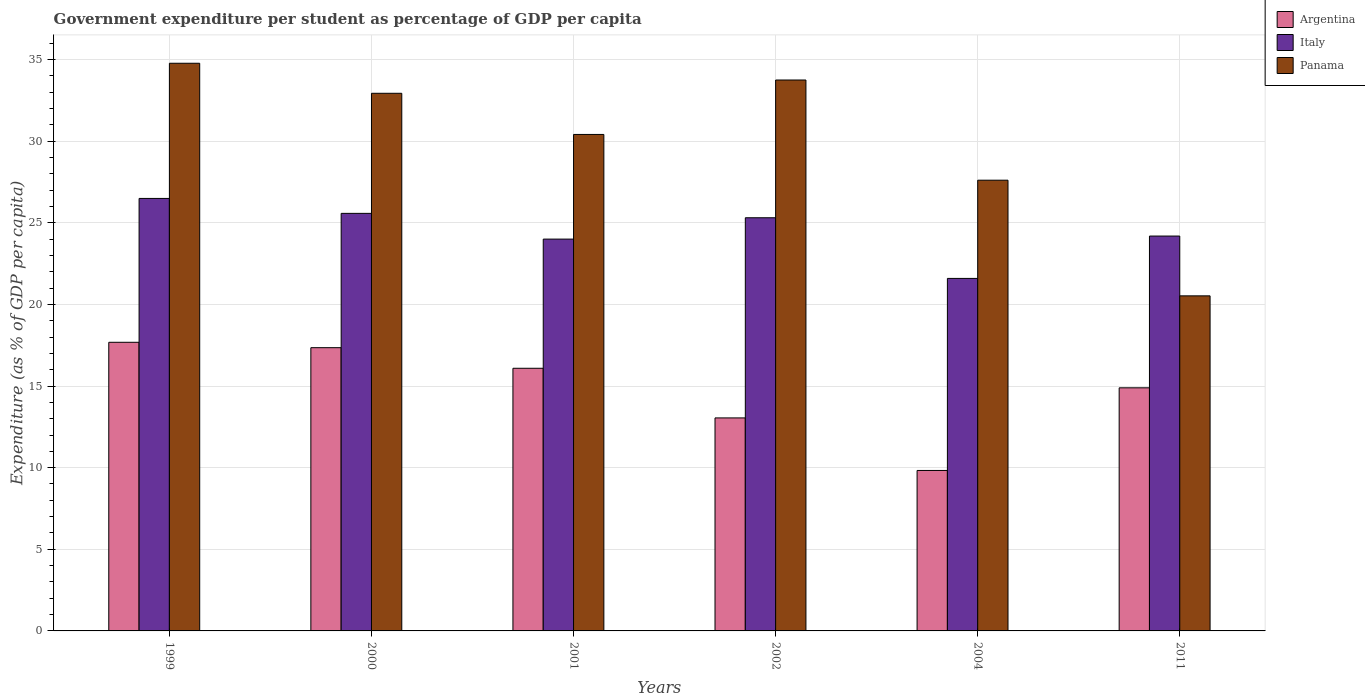How many groups of bars are there?
Offer a terse response. 6. Are the number of bars per tick equal to the number of legend labels?
Provide a short and direct response. Yes. Are the number of bars on each tick of the X-axis equal?
Offer a very short reply. Yes. How many bars are there on the 4th tick from the left?
Your answer should be very brief. 3. What is the percentage of expenditure per student in Panama in 1999?
Your answer should be compact. 34.77. Across all years, what is the maximum percentage of expenditure per student in Argentina?
Offer a terse response. 17.68. Across all years, what is the minimum percentage of expenditure per student in Argentina?
Provide a succinct answer. 9.83. In which year was the percentage of expenditure per student in Argentina maximum?
Provide a succinct answer. 1999. What is the total percentage of expenditure per student in Italy in the graph?
Ensure brevity in your answer.  147.15. What is the difference between the percentage of expenditure per student in Argentina in 2001 and that in 2002?
Provide a succinct answer. 3.04. What is the difference between the percentage of expenditure per student in Argentina in 2000 and the percentage of expenditure per student in Italy in 2004?
Provide a succinct answer. -4.24. What is the average percentage of expenditure per student in Argentina per year?
Ensure brevity in your answer.  14.81. In the year 1999, what is the difference between the percentage of expenditure per student in Argentina and percentage of expenditure per student in Panama?
Offer a terse response. -17.09. In how many years, is the percentage of expenditure per student in Argentina greater than 14 %?
Your response must be concise. 4. What is the ratio of the percentage of expenditure per student in Argentina in 2000 to that in 2002?
Your answer should be very brief. 1.33. Is the percentage of expenditure per student in Argentina in 2000 less than that in 2002?
Make the answer very short. No. Is the difference between the percentage of expenditure per student in Argentina in 2002 and 2011 greater than the difference between the percentage of expenditure per student in Panama in 2002 and 2011?
Your answer should be compact. No. What is the difference between the highest and the second highest percentage of expenditure per student in Italy?
Offer a very short reply. 0.92. What is the difference between the highest and the lowest percentage of expenditure per student in Panama?
Your answer should be very brief. 14.25. In how many years, is the percentage of expenditure per student in Argentina greater than the average percentage of expenditure per student in Argentina taken over all years?
Ensure brevity in your answer.  4. What does the 3rd bar from the left in 2000 represents?
Your response must be concise. Panama. What does the 1st bar from the right in 2011 represents?
Provide a short and direct response. Panama. How many bars are there?
Make the answer very short. 18. What is the difference between two consecutive major ticks on the Y-axis?
Offer a terse response. 5. Where does the legend appear in the graph?
Provide a short and direct response. Top right. How many legend labels are there?
Give a very brief answer. 3. What is the title of the graph?
Your response must be concise. Government expenditure per student as percentage of GDP per capita. What is the label or title of the Y-axis?
Provide a short and direct response. Expenditure (as % of GDP per capita). What is the Expenditure (as % of GDP per capita) of Argentina in 1999?
Offer a very short reply. 17.68. What is the Expenditure (as % of GDP per capita) of Italy in 1999?
Give a very brief answer. 26.49. What is the Expenditure (as % of GDP per capita) in Panama in 1999?
Offer a terse response. 34.77. What is the Expenditure (as % of GDP per capita) in Argentina in 2000?
Make the answer very short. 17.35. What is the Expenditure (as % of GDP per capita) in Italy in 2000?
Give a very brief answer. 25.57. What is the Expenditure (as % of GDP per capita) of Panama in 2000?
Offer a terse response. 32.93. What is the Expenditure (as % of GDP per capita) in Argentina in 2001?
Give a very brief answer. 16.09. What is the Expenditure (as % of GDP per capita) in Italy in 2001?
Keep it short and to the point. 24. What is the Expenditure (as % of GDP per capita) in Panama in 2001?
Keep it short and to the point. 30.41. What is the Expenditure (as % of GDP per capita) of Argentina in 2002?
Your response must be concise. 13.05. What is the Expenditure (as % of GDP per capita) of Italy in 2002?
Your answer should be very brief. 25.31. What is the Expenditure (as % of GDP per capita) in Panama in 2002?
Keep it short and to the point. 33.74. What is the Expenditure (as % of GDP per capita) in Argentina in 2004?
Give a very brief answer. 9.83. What is the Expenditure (as % of GDP per capita) of Italy in 2004?
Your answer should be compact. 21.59. What is the Expenditure (as % of GDP per capita) in Panama in 2004?
Keep it short and to the point. 27.61. What is the Expenditure (as % of GDP per capita) of Argentina in 2011?
Offer a terse response. 14.89. What is the Expenditure (as % of GDP per capita) in Italy in 2011?
Your answer should be compact. 24.19. What is the Expenditure (as % of GDP per capita) in Panama in 2011?
Provide a succinct answer. 20.52. Across all years, what is the maximum Expenditure (as % of GDP per capita) in Argentina?
Ensure brevity in your answer.  17.68. Across all years, what is the maximum Expenditure (as % of GDP per capita) in Italy?
Offer a very short reply. 26.49. Across all years, what is the maximum Expenditure (as % of GDP per capita) of Panama?
Your answer should be very brief. 34.77. Across all years, what is the minimum Expenditure (as % of GDP per capita) in Argentina?
Offer a very short reply. 9.83. Across all years, what is the minimum Expenditure (as % of GDP per capita) in Italy?
Offer a very short reply. 21.59. Across all years, what is the minimum Expenditure (as % of GDP per capita) of Panama?
Your response must be concise. 20.52. What is the total Expenditure (as % of GDP per capita) of Argentina in the graph?
Give a very brief answer. 88.88. What is the total Expenditure (as % of GDP per capita) in Italy in the graph?
Make the answer very short. 147.15. What is the total Expenditure (as % of GDP per capita) in Panama in the graph?
Offer a very short reply. 179.98. What is the difference between the Expenditure (as % of GDP per capita) of Argentina in 1999 and that in 2000?
Keep it short and to the point. 0.33. What is the difference between the Expenditure (as % of GDP per capita) of Italy in 1999 and that in 2000?
Provide a succinct answer. 0.92. What is the difference between the Expenditure (as % of GDP per capita) in Panama in 1999 and that in 2000?
Give a very brief answer. 1.84. What is the difference between the Expenditure (as % of GDP per capita) of Argentina in 1999 and that in 2001?
Make the answer very short. 1.59. What is the difference between the Expenditure (as % of GDP per capita) in Italy in 1999 and that in 2001?
Ensure brevity in your answer.  2.49. What is the difference between the Expenditure (as % of GDP per capita) of Panama in 1999 and that in 2001?
Offer a terse response. 4.36. What is the difference between the Expenditure (as % of GDP per capita) of Argentina in 1999 and that in 2002?
Offer a very short reply. 4.63. What is the difference between the Expenditure (as % of GDP per capita) of Italy in 1999 and that in 2002?
Offer a terse response. 1.18. What is the difference between the Expenditure (as % of GDP per capita) in Panama in 1999 and that in 2002?
Your response must be concise. 1.03. What is the difference between the Expenditure (as % of GDP per capita) in Argentina in 1999 and that in 2004?
Provide a short and direct response. 7.85. What is the difference between the Expenditure (as % of GDP per capita) of Italy in 1999 and that in 2004?
Offer a very short reply. 4.9. What is the difference between the Expenditure (as % of GDP per capita) in Panama in 1999 and that in 2004?
Offer a terse response. 7.16. What is the difference between the Expenditure (as % of GDP per capita) in Argentina in 1999 and that in 2011?
Offer a very short reply. 2.79. What is the difference between the Expenditure (as % of GDP per capita) in Italy in 1999 and that in 2011?
Provide a short and direct response. 2.3. What is the difference between the Expenditure (as % of GDP per capita) of Panama in 1999 and that in 2011?
Offer a terse response. 14.25. What is the difference between the Expenditure (as % of GDP per capita) in Argentina in 2000 and that in 2001?
Your response must be concise. 1.26. What is the difference between the Expenditure (as % of GDP per capita) in Italy in 2000 and that in 2001?
Provide a succinct answer. 1.58. What is the difference between the Expenditure (as % of GDP per capita) in Panama in 2000 and that in 2001?
Keep it short and to the point. 2.52. What is the difference between the Expenditure (as % of GDP per capita) in Argentina in 2000 and that in 2002?
Offer a very short reply. 4.3. What is the difference between the Expenditure (as % of GDP per capita) of Italy in 2000 and that in 2002?
Make the answer very short. 0.27. What is the difference between the Expenditure (as % of GDP per capita) in Panama in 2000 and that in 2002?
Your answer should be compact. -0.81. What is the difference between the Expenditure (as % of GDP per capita) in Argentina in 2000 and that in 2004?
Offer a very short reply. 7.52. What is the difference between the Expenditure (as % of GDP per capita) of Italy in 2000 and that in 2004?
Give a very brief answer. 3.98. What is the difference between the Expenditure (as % of GDP per capita) in Panama in 2000 and that in 2004?
Ensure brevity in your answer.  5.32. What is the difference between the Expenditure (as % of GDP per capita) in Argentina in 2000 and that in 2011?
Keep it short and to the point. 2.46. What is the difference between the Expenditure (as % of GDP per capita) of Italy in 2000 and that in 2011?
Keep it short and to the point. 1.39. What is the difference between the Expenditure (as % of GDP per capita) of Panama in 2000 and that in 2011?
Offer a terse response. 12.41. What is the difference between the Expenditure (as % of GDP per capita) in Argentina in 2001 and that in 2002?
Provide a succinct answer. 3.04. What is the difference between the Expenditure (as % of GDP per capita) of Italy in 2001 and that in 2002?
Ensure brevity in your answer.  -1.31. What is the difference between the Expenditure (as % of GDP per capita) in Panama in 2001 and that in 2002?
Provide a short and direct response. -3.33. What is the difference between the Expenditure (as % of GDP per capita) of Argentina in 2001 and that in 2004?
Provide a succinct answer. 6.26. What is the difference between the Expenditure (as % of GDP per capita) of Italy in 2001 and that in 2004?
Ensure brevity in your answer.  2.41. What is the difference between the Expenditure (as % of GDP per capita) in Panama in 2001 and that in 2004?
Give a very brief answer. 2.8. What is the difference between the Expenditure (as % of GDP per capita) of Argentina in 2001 and that in 2011?
Give a very brief answer. 1.2. What is the difference between the Expenditure (as % of GDP per capita) in Italy in 2001 and that in 2011?
Provide a succinct answer. -0.19. What is the difference between the Expenditure (as % of GDP per capita) of Panama in 2001 and that in 2011?
Keep it short and to the point. 9.89. What is the difference between the Expenditure (as % of GDP per capita) of Argentina in 2002 and that in 2004?
Your response must be concise. 3.22. What is the difference between the Expenditure (as % of GDP per capita) in Italy in 2002 and that in 2004?
Offer a very short reply. 3.72. What is the difference between the Expenditure (as % of GDP per capita) in Panama in 2002 and that in 2004?
Give a very brief answer. 6.14. What is the difference between the Expenditure (as % of GDP per capita) of Argentina in 2002 and that in 2011?
Offer a terse response. -1.84. What is the difference between the Expenditure (as % of GDP per capita) in Italy in 2002 and that in 2011?
Your answer should be compact. 1.12. What is the difference between the Expenditure (as % of GDP per capita) in Panama in 2002 and that in 2011?
Your response must be concise. 13.22. What is the difference between the Expenditure (as % of GDP per capita) in Argentina in 2004 and that in 2011?
Ensure brevity in your answer.  -5.06. What is the difference between the Expenditure (as % of GDP per capita) of Italy in 2004 and that in 2011?
Provide a succinct answer. -2.59. What is the difference between the Expenditure (as % of GDP per capita) in Panama in 2004 and that in 2011?
Keep it short and to the point. 7.08. What is the difference between the Expenditure (as % of GDP per capita) in Argentina in 1999 and the Expenditure (as % of GDP per capita) in Italy in 2000?
Your answer should be compact. -7.9. What is the difference between the Expenditure (as % of GDP per capita) of Argentina in 1999 and the Expenditure (as % of GDP per capita) of Panama in 2000?
Your answer should be very brief. -15.25. What is the difference between the Expenditure (as % of GDP per capita) in Italy in 1999 and the Expenditure (as % of GDP per capita) in Panama in 2000?
Your answer should be very brief. -6.44. What is the difference between the Expenditure (as % of GDP per capita) of Argentina in 1999 and the Expenditure (as % of GDP per capita) of Italy in 2001?
Your answer should be compact. -6.32. What is the difference between the Expenditure (as % of GDP per capita) of Argentina in 1999 and the Expenditure (as % of GDP per capita) of Panama in 2001?
Keep it short and to the point. -12.73. What is the difference between the Expenditure (as % of GDP per capita) in Italy in 1999 and the Expenditure (as % of GDP per capita) in Panama in 2001?
Offer a terse response. -3.92. What is the difference between the Expenditure (as % of GDP per capita) in Argentina in 1999 and the Expenditure (as % of GDP per capita) in Italy in 2002?
Provide a short and direct response. -7.63. What is the difference between the Expenditure (as % of GDP per capita) in Argentina in 1999 and the Expenditure (as % of GDP per capita) in Panama in 2002?
Make the answer very short. -16.06. What is the difference between the Expenditure (as % of GDP per capita) of Italy in 1999 and the Expenditure (as % of GDP per capita) of Panama in 2002?
Keep it short and to the point. -7.25. What is the difference between the Expenditure (as % of GDP per capita) in Argentina in 1999 and the Expenditure (as % of GDP per capita) in Italy in 2004?
Provide a short and direct response. -3.91. What is the difference between the Expenditure (as % of GDP per capita) in Argentina in 1999 and the Expenditure (as % of GDP per capita) in Panama in 2004?
Make the answer very short. -9.93. What is the difference between the Expenditure (as % of GDP per capita) of Italy in 1999 and the Expenditure (as % of GDP per capita) of Panama in 2004?
Keep it short and to the point. -1.12. What is the difference between the Expenditure (as % of GDP per capita) in Argentina in 1999 and the Expenditure (as % of GDP per capita) in Italy in 2011?
Provide a succinct answer. -6.51. What is the difference between the Expenditure (as % of GDP per capita) in Argentina in 1999 and the Expenditure (as % of GDP per capita) in Panama in 2011?
Offer a very short reply. -2.84. What is the difference between the Expenditure (as % of GDP per capita) of Italy in 1999 and the Expenditure (as % of GDP per capita) of Panama in 2011?
Offer a terse response. 5.97. What is the difference between the Expenditure (as % of GDP per capita) in Argentina in 2000 and the Expenditure (as % of GDP per capita) in Italy in 2001?
Make the answer very short. -6.65. What is the difference between the Expenditure (as % of GDP per capita) in Argentina in 2000 and the Expenditure (as % of GDP per capita) in Panama in 2001?
Make the answer very short. -13.06. What is the difference between the Expenditure (as % of GDP per capita) of Italy in 2000 and the Expenditure (as % of GDP per capita) of Panama in 2001?
Your response must be concise. -4.83. What is the difference between the Expenditure (as % of GDP per capita) in Argentina in 2000 and the Expenditure (as % of GDP per capita) in Italy in 2002?
Ensure brevity in your answer.  -7.96. What is the difference between the Expenditure (as % of GDP per capita) of Argentina in 2000 and the Expenditure (as % of GDP per capita) of Panama in 2002?
Provide a succinct answer. -16.39. What is the difference between the Expenditure (as % of GDP per capita) in Italy in 2000 and the Expenditure (as % of GDP per capita) in Panama in 2002?
Ensure brevity in your answer.  -8.17. What is the difference between the Expenditure (as % of GDP per capita) in Argentina in 2000 and the Expenditure (as % of GDP per capita) in Italy in 2004?
Offer a very short reply. -4.24. What is the difference between the Expenditure (as % of GDP per capita) in Argentina in 2000 and the Expenditure (as % of GDP per capita) in Panama in 2004?
Offer a terse response. -10.26. What is the difference between the Expenditure (as % of GDP per capita) in Italy in 2000 and the Expenditure (as % of GDP per capita) in Panama in 2004?
Your response must be concise. -2.03. What is the difference between the Expenditure (as % of GDP per capita) of Argentina in 2000 and the Expenditure (as % of GDP per capita) of Italy in 2011?
Ensure brevity in your answer.  -6.84. What is the difference between the Expenditure (as % of GDP per capita) of Argentina in 2000 and the Expenditure (as % of GDP per capita) of Panama in 2011?
Your answer should be very brief. -3.17. What is the difference between the Expenditure (as % of GDP per capita) of Italy in 2000 and the Expenditure (as % of GDP per capita) of Panama in 2011?
Provide a short and direct response. 5.05. What is the difference between the Expenditure (as % of GDP per capita) of Argentina in 2001 and the Expenditure (as % of GDP per capita) of Italy in 2002?
Offer a terse response. -9.22. What is the difference between the Expenditure (as % of GDP per capita) in Argentina in 2001 and the Expenditure (as % of GDP per capita) in Panama in 2002?
Ensure brevity in your answer.  -17.66. What is the difference between the Expenditure (as % of GDP per capita) of Italy in 2001 and the Expenditure (as % of GDP per capita) of Panama in 2002?
Your answer should be very brief. -9.74. What is the difference between the Expenditure (as % of GDP per capita) of Argentina in 2001 and the Expenditure (as % of GDP per capita) of Italy in 2004?
Make the answer very short. -5.5. What is the difference between the Expenditure (as % of GDP per capita) of Argentina in 2001 and the Expenditure (as % of GDP per capita) of Panama in 2004?
Provide a short and direct response. -11.52. What is the difference between the Expenditure (as % of GDP per capita) of Italy in 2001 and the Expenditure (as % of GDP per capita) of Panama in 2004?
Offer a terse response. -3.61. What is the difference between the Expenditure (as % of GDP per capita) in Argentina in 2001 and the Expenditure (as % of GDP per capita) in Italy in 2011?
Keep it short and to the point. -8.1. What is the difference between the Expenditure (as % of GDP per capita) of Argentina in 2001 and the Expenditure (as % of GDP per capita) of Panama in 2011?
Your answer should be very brief. -4.44. What is the difference between the Expenditure (as % of GDP per capita) in Italy in 2001 and the Expenditure (as % of GDP per capita) in Panama in 2011?
Give a very brief answer. 3.48. What is the difference between the Expenditure (as % of GDP per capita) of Argentina in 2002 and the Expenditure (as % of GDP per capita) of Italy in 2004?
Offer a very short reply. -8.54. What is the difference between the Expenditure (as % of GDP per capita) of Argentina in 2002 and the Expenditure (as % of GDP per capita) of Panama in 2004?
Your answer should be very brief. -14.56. What is the difference between the Expenditure (as % of GDP per capita) in Italy in 2002 and the Expenditure (as % of GDP per capita) in Panama in 2004?
Give a very brief answer. -2.3. What is the difference between the Expenditure (as % of GDP per capita) in Argentina in 2002 and the Expenditure (as % of GDP per capita) in Italy in 2011?
Give a very brief answer. -11.14. What is the difference between the Expenditure (as % of GDP per capita) of Argentina in 2002 and the Expenditure (as % of GDP per capita) of Panama in 2011?
Your response must be concise. -7.48. What is the difference between the Expenditure (as % of GDP per capita) in Italy in 2002 and the Expenditure (as % of GDP per capita) in Panama in 2011?
Offer a terse response. 4.78. What is the difference between the Expenditure (as % of GDP per capita) of Argentina in 2004 and the Expenditure (as % of GDP per capita) of Italy in 2011?
Keep it short and to the point. -14.36. What is the difference between the Expenditure (as % of GDP per capita) of Argentina in 2004 and the Expenditure (as % of GDP per capita) of Panama in 2011?
Provide a succinct answer. -10.69. What is the difference between the Expenditure (as % of GDP per capita) in Italy in 2004 and the Expenditure (as % of GDP per capita) in Panama in 2011?
Make the answer very short. 1.07. What is the average Expenditure (as % of GDP per capita) in Argentina per year?
Provide a succinct answer. 14.81. What is the average Expenditure (as % of GDP per capita) in Italy per year?
Provide a short and direct response. 24.52. What is the average Expenditure (as % of GDP per capita) of Panama per year?
Give a very brief answer. 30. In the year 1999, what is the difference between the Expenditure (as % of GDP per capita) in Argentina and Expenditure (as % of GDP per capita) in Italy?
Your answer should be compact. -8.81. In the year 1999, what is the difference between the Expenditure (as % of GDP per capita) of Argentina and Expenditure (as % of GDP per capita) of Panama?
Offer a very short reply. -17.09. In the year 1999, what is the difference between the Expenditure (as % of GDP per capita) of Italy and Expenditure (as % of GDP per capita) of Panama?
Make the answer very short. -8.28. In the year 2000, what is the difference between the Expenditure (as % of GDP per capita) in Argentina and Expenditure (as % of GDP per capita) in Italy?
Offer a terse response. -8.23. In the year 2000, what is the difference between the Expenditure (as % of GDP per capita) of Argentina and Expenditure (as % of GDP per capita) of Panama?
Ensure brevity in your answer.  -15.58. In the year 2000, what is the difference between the Expenditure (as % of GDP per capita) in Italy and Expenditure (as % of GDP per capita) in Panama?
Your response must be concise. -7.36. In the year 2001, what is the difference between the Expenditure (as % of GDP per capita) in Argentina and Expenditure (as % of GDP per capita) in Italy?
Provide a succinct answer. -7.91. In the year 2001, what is the difference between the Expenditure (as % of GDP per capita) in Argentina and Expenditure (as % of GDP per capita) in Panama?
Ensure brevity in your answer.  -14.32. In the year 2001, what is the difference between the Expenditure (as % of GDP per capita) in Italy and Expenditure (as % of GDP per capita) in Panama?
Keep it short and to the point. -6.41. In the year 2002, what is the difference between the Expenditure (as % of GDP per capita) in Argentina and Expenditure (as % of GDP per capita) in Italy?
Your answer should be very brief. -12.26. In the year 2002, what is the difference between the Expenditure (as % of GDP per capita) of Argentina and Expenditure (as % of GDP per capita) of Panama?
Your answer should be very brief. -20.7. In the year 2002, what is the difference between the Expenditure (as % of GDP per capita) of Italy and Expenditure (as % of GDP per capita) of Panama?
Give a very brief answer. -8.44. In the year 2004, what is the difference between the Expenditure (as % of GDP per capita) in Argentina and Expenditure (as % of GDP per capita) in Italy?
Your answer should be very brief. -11.76. In the year 2004, what is the difference between the Expenditure (as % of GDP per capita) in Argentina and Expenditure (as % of GDP per capita) in Panama?
Your response must be concise. -17.78. In the year 2004, what is the difference between the Expenditure (as % of GDP per capita) in Italy and Expenditure (as % of GDP per capita) in Panama?
Keep it short and to the point. -6.02. In the year 2011, what is the difference between the Expenditure (as % of GDP per capita) in Argentina and Expenditure (as % of GDP per capita) in Italy?
Provide a succinct answer. -9.3. In the year 2011, what is the difference between the Expenditure (as % of GDP per capita) of Argentina and Expenditure (as % of GDP per capita) of Panama?
Keep it short and to the point. -5.63. In the year 2011, what is the difference between the Expenditure (as % of GDP per capita) of Italy and Expenditure (as % of GDP per capita) of Panama?
Ensure brevity in your answer.  3.66. What is the ratio of the Expenditure (as % of GDP per capita) in Argentina in 1999 to that in 2000?
Provide a succinct answer. 1.02. What is the ratio of the Expenditure (as % of GDP per capita) of Italy in 1999 to that in 2000?
Your response must be concise. 1.04. What is the ratio of the Expenditure (as % of GDP per capita) of Panama in 1999 to that in 2000?
Ensure brevity in your answer.  1.06. What is the ratio of the Expenditure (as % of GDP per capita) of Argentina in 1999 to that in 2001?
Your answer should be compact. 1.1. What is the ratio of the Expenditure (as % of GDP per capita) of Italy in 1999 to that in 2001?
Provide a short and direct response. 1.1. What is the ratio of the Expenditure (as % of GDP per capita) in Panama in 1999 to that in 2001?
Offer a very short reply. 1.14. What is the ratio of the Expenditure (as % of GDP per capita) in Argentina in 1999 to that in 2002?
Offer a very short reply. 1.35. What is the ratio of the Expenditure (as % of GDP per capita) of Italy in 1999 to that in 2002?
Your answer should be very brief. 1.05. What is the ratio of the Expenditure (as % of GDP per capita) in Panama in 1999 to that in 2002?
Your answer should be very brief. 1.03. What is the ratio of the Expenditure (as % of GDP per capita) in Argentina in 1999 to that in 2004?
Offer a very short reply. 1.8. What is the ratio of the Expenditure (as % of GDP per capita) in Italy in 1999 to that in 2004?
Make the answer very short. 1.23. What is the ratio of the Expenditure (as % of GDP per capita) in Panama in 1999 to that in 2004?
Provide a succinct answer. 1.26. What is the ratio of the Expenditure (as % of GDP per capita) of Argentina in 1999 to that in 2011?
Your answer should be compact. 1.19. What is the ratio of the Expenditure (as % of GDP per capita) in Italy in 1999 to that in 2011?
Offer a very short reply. 1.1. What is the ratio of the Expenditure (as % of GDP per capita) in Panama in 1999 to that in 2011?
Give a very brief answer. 1.69. What is the ratio of the Expenditure (as % of GDP per capita) in Argentina in 2000 to that in 2001?
Your answer should be very brief. 1.08. What is the ratio of the Expenditure (as % of GDP per capita) of Italy in 2000 to that in 2001?
Keep it short and to the point. 1.07. What is the ratio of the Expenditure (as % of GDP per capita) in Panama in 2000 to that in 2001?
Your answer should be compact. 1.08. What is the ratio of the Expenditure (as % of GDP per capita) of Argentina in 2000 to that in 2002?
Your answer should be very brief. 1.33. What is the ratio of the Expenditure (as % of GDP per capita) in Italy in 2000 to that in 2002?
Keep it short and to the point. 1.01. What is the ratio of the Expenditure (as % of GDP per capita) of Panama in 2000 to that in 2002?
Ensure brevity in your answer.  0.98. What is the ratio of the Expenditure (as % of GDP per capita) in Argentina in 2000 to that in 2004?
Make the answer very short. 1.77. What is the ratio of the Expenditure (as % of GDP per capita) in Italy in 2000 to that in 2004?
Your answer should be compact. 1.18. What is the ratio of the Expenditure (as % of GDP per capita) of Panama in 2000 to that in 2004?
Provide a short and direct response. 1.19. What is the ratio of the Expenditure (as % of GDP per capita) in Argentina in 2000 to that in 2011?
Ensure brevity in your answer.  1.17. What is the ratio of the Expenditure (as % of GDP per capita) of Italy in 2000 to that in 2011?
Offer a terse response. 1.06. What is the ratio of the Expenditure (as % of GDP per capita) of Panama in 2000 to that in 2011?
Offer a very short reply. 1.6. What is the ratio of the Expenditure (as % of GDP per capita) of Argentina in 2001 to that in 2002?
Offer a terse response. 1.23. What is the ratio of the Expenditure (as % of GDP per capita) in Italy in 2001 to that in 2002?
Ensure brevity in your answer.  0.95. What is the ratio of the Expenditure (as % of GDP per capita) in Panama in 2001 to that in 2002?
Your response must be concise. 0.9. What is the ratio of the Expenditure (as % of GDP per capita) in Argentina in 2001 to that in 2004?
Ensure brevity in your answer.  1.64. What is the ratio of the Expenditure (as % of GDP per capita) in Italy in 2001 to that in 2004?
Your answer should be very brief. 1.11. What is the ratio of the Expenditure (as % of GDP per capita) of Panama in 2001 to that in 2004?
Ensure brevity in your answer.  1.1. What is the ratio of the Expenditure (as % of GDP per capita) in Argentina in 2001 to that in 2011?
Provide a succinct answer. 1.08. What is the ratio of the Expenditure (as % of GDP per capita) of Italy in 2001 to that in 2011?
Offer a very short reply. 0.99. What is the ratio of the Expenditure (as % of GDP per capita) of Panama in 2001 to that in 2011?
Make the answer very short. 1.48. What is the ratio of the Expenditure (as % of GDP per capita) of Argentina in 2002 to that in 2004?
Keep it short and to the point. 1.33. What is the ratio of the Expenditure (as % of GDP per capita) of Italy in 2002 to that in 2004?
Offer a terse response. 1.17. What is the ratio of the Expenditure (as % of GDP per capita) in Panama in 2002 to that in 2004?
Provide a succinct answer. 1.22. What is the ratio of the Expenditure (as % of GDP per capita) of Argentina in 2002 to that in 2011?
Offer a very short reply. 0.88. What is the ratio of the Expenditure (as % of GDP per capita) of Italy in 2002 to that in 2011?
Give a very brief answer. 1.05. What is the ratio of the Expenditure (as % of GDP per capita) of Panama in 2002 to that in 2011?
Make the answer very short. 1.64. What is the ratio of the Expenditure (as % of GDP per capita) in Argentina in 2004 to that in 2011?
Give a very brief answer. 0.66. What is the ratio of the Expenditure (as % of GDP per capita) in Italy in 2004 to that in 2011?
Provide a succinct answer. 0.89. What is the ratio of the Expenditure (as % of GDP per capita) in Panama in 2004 to that in 2011?
Offer a very short reply. 1.35. What is the difference between the highest and the second highest Expenditure (as % of GDP per capita) of Argentina?
Give a very brief answer. 0.33. What is the difference between the highest and the second highest Expenditure (as % of GDP per capita) of Italy?
Ensure brevity in your answer.  0.92. What is the difference between the highest and the second highest Expenditure (as % of GDP per capita) in Panama?
Give a very brief answer. 1.03. What is the difference between the highest and the lowest Expenditure (as % of GDP per capita) in Argentina?
Offer a terse response. 7.85. What is the difference between the highest and the lowest Expenditure (as % of GDP per capita) in Italy?
Give a very brief answer. 4.9. What is the difference between the highest and the lowest Expenditure (as % of GDP per capita) in Panama?
Provide a short and direct response. 14.25. 